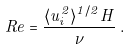Convert formula to latex. <formula><loc_0><loc_0><loc_500><loc_500>R e = \frac { \langle u _ { i } ^ { 2 } \rangle ^ { 1 / 2 } H } { \nu } \, .</formula> 